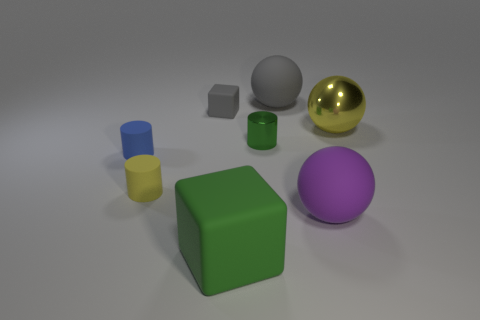Subtract all tiny yellow matte cylinders. How many cylinders are left? 2 Add 2 big blocks. How many objects exist? 10 Subtract all balls. How many objects are left? 5 Subtract all blue cylinders. How many cylinders are left? 2 Subtract all red spheres. How many gray blocks are left? 1 Subtract all tiny green metal spheres. Subtract all small shiny objects. How many objects are left? 7 Add 8 blue things. How many blue things are left? 9 Add 6 brown rubber cubes. How many brown rubber cubes exist? 6 Subtract 1 gray blocks. How many objects are left? 7 Subtract 1 spheres. How many spheres are left? 2 